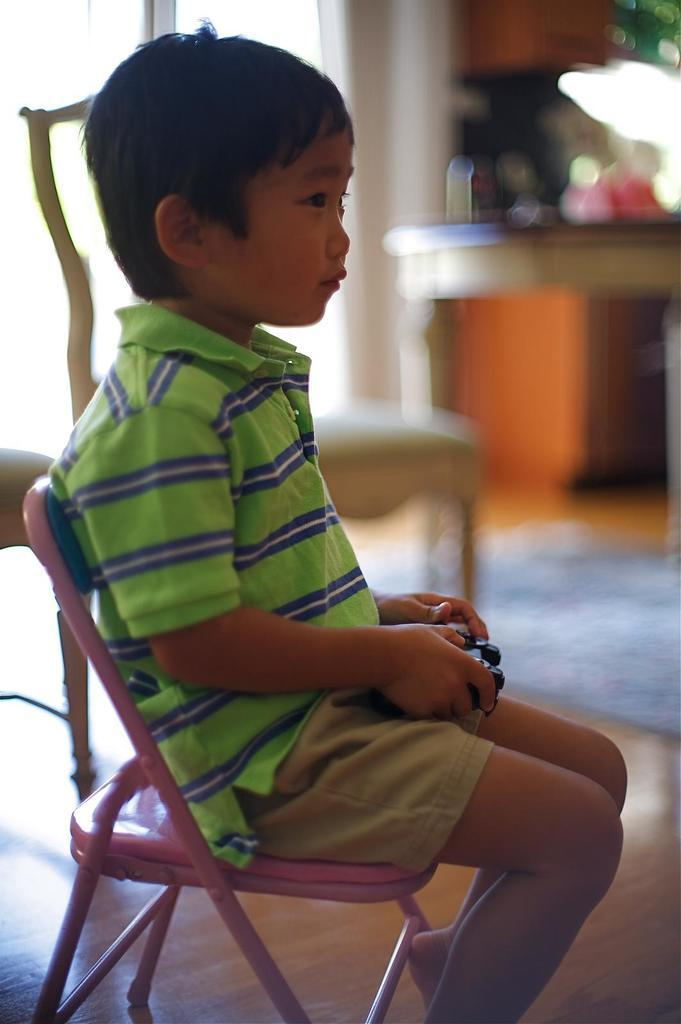Who is the main subject in the image? There is a boy in the image. What is the boy doing in the image? The boy is sitting in a chair. What can be seen in the background of the image? There is a table in the background of the image. What type of bubble can be seen floating near the boy in the image? There is no bubble present in the image; it only features a boy sitting in a chair and a table in the background. 